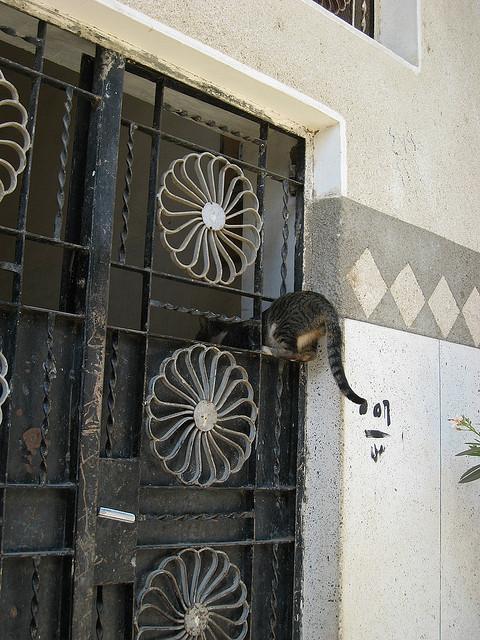How many cars do you see?
Give a very brief answer. 0. 